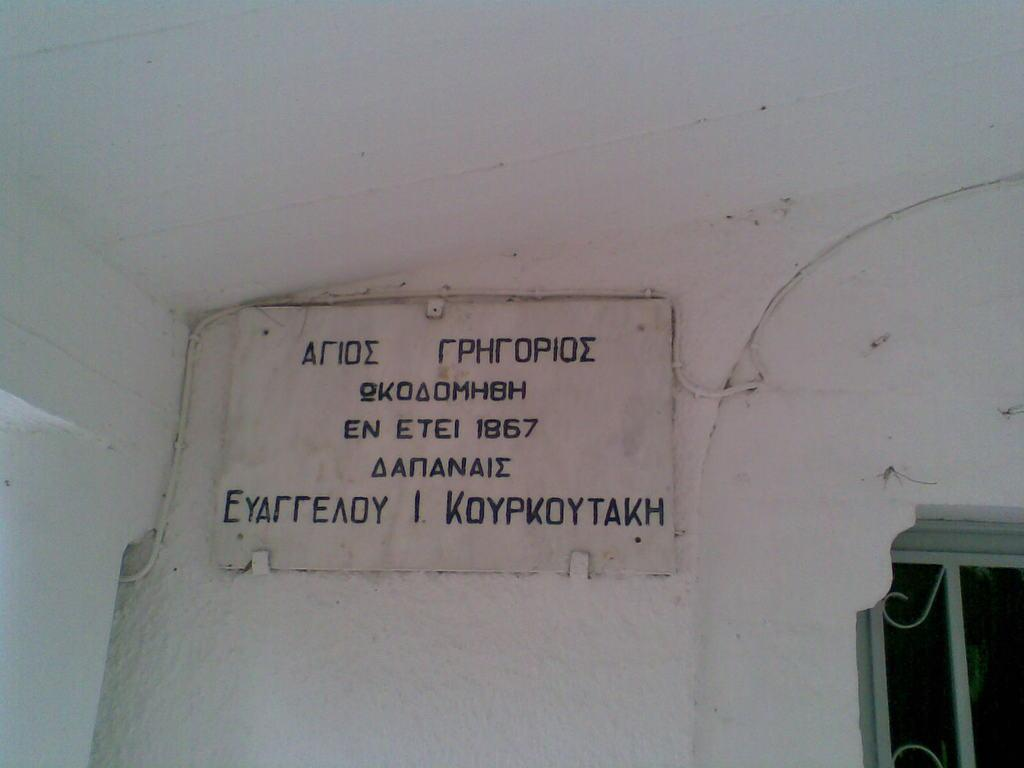What is written on the white wall in the image? There is a name board with text on a white wall in the image. What can be seen on the right side of the image? There is a grill on the right side of the image. Can you describe the woman's invention on the left side of the image? There is no woman or invention present in the image; it only features a name board with text on a white wall and a grill on the right side. What color is the lip of the person in the image? There is no person present in the image, so it is not possible to describe the color of their lip. 